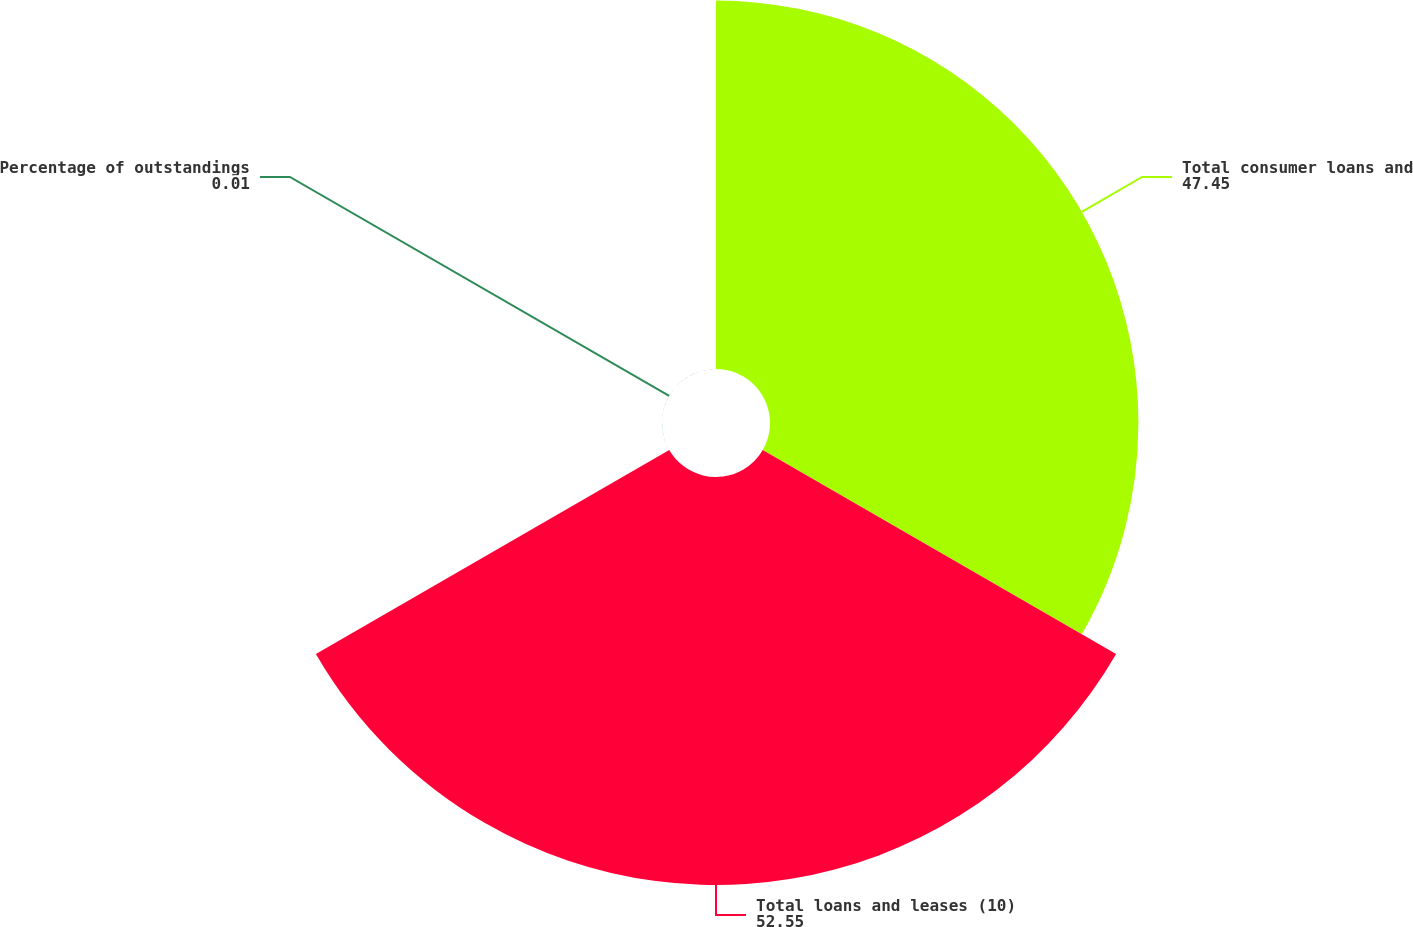<chart> <loc_0><loc_0><loc_500><loc_500><pie_chart><fcel>Total consumer loans and<fcel>Total loans and leases (10)<fcel>Percentage of outstandings<nl><fcel>47.45%<fcel>52.55%<fcel>0.01%<nl></chart> 